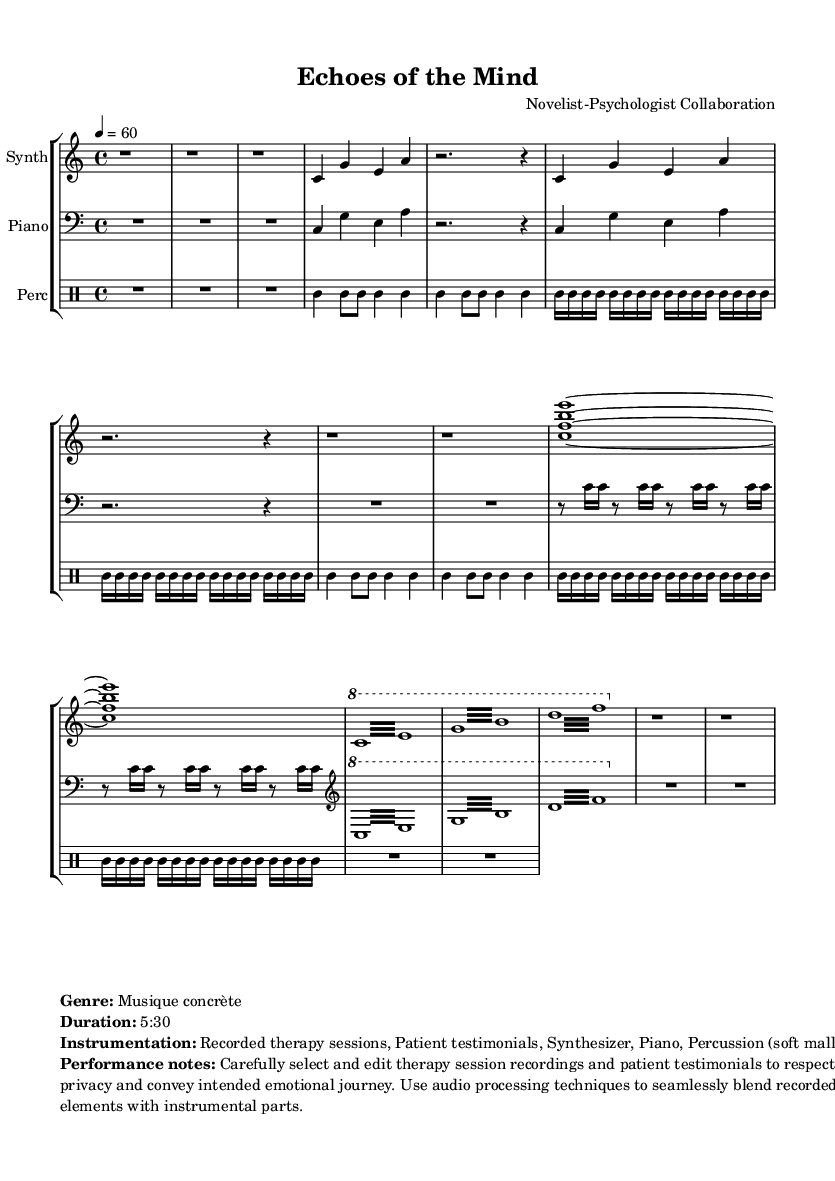What is the time signature of this music? The time signature is indicated at the beginning of the score as 4/4, meaning there are four beats in a measure, and the quarter note gets one beat.
Answer: 4/4 What is the tempo of the piece? The tempo is provided in the beginning marking, showing the speed of the piece, which is set at 60 beats per minute.
Answer: 60 How many sections are in the piece? The score is structured into multiple labeled sections: Introduction, Section A, Interlude, Section B, Climax, and Outro, making a total of 6 distinct sections.
Answer: 6 What instruments are used in this composition? The score lists the instrumentation as Synthesizer, Piano, and Percussion (soft mallets), along with recorded therapy sessions and patient testimonials, creating a unique blend.
Answer: Synthesizer, Piano, Percussion What is the duration of "Echoes of the Mind"? The duration is indicated in the markup as 5 minutes and 30 seconds, denoting the total expected performance time for the piece.
Answer: 5:30 How does the climax section differ from the other sections? The Climax section employs rapid repeated notes and tremolo effects across multiple pitches, contrasting with the more melodic and slower characteristics of the previous sections.
Answer: Rapid repeated notes What is a key characteristic of Musique concrète as used in this piece? A key characteristic is the incorporation of recorded sounds from therapy sessions and testimonials, which are blended with instrumental parts using audio processing techniques to create an emotional experience.
Answer: Recorded therapy sessions 